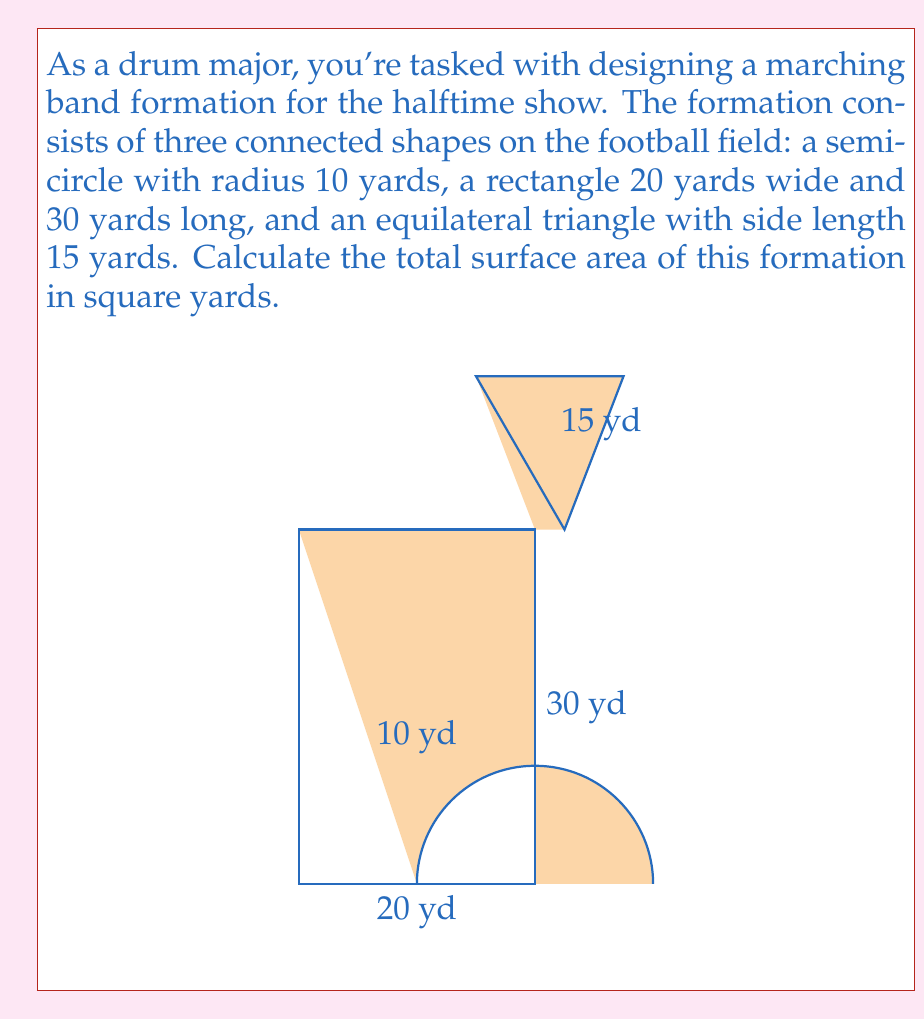Can you solve this math problem? Let's break this down step-by-step:

1) Semicircle area:
   The area of a semicircle is given by $A = \frac{1}{2} \pi r^2$
   $$A_{semicircle} = \frac{1}{2} \pi (10)^2 = 50\pi \text{ square yards}$$

2) Rectangle area:
   The area of a rectangle is length times width
   $$A_{rectangle} = 20 \times 30 = 600 \text{ square yards}$$

3) Equilateral triangle area:
   The area of an equilateral triangle is given by $A = \frac{\sqrt{3}}{4}a^2$, where $a$ is the side length
   $$A_{triangle} = \frac{\sqrt{3}}{4}(15)^2 = \frac{225\sqrt{3}}{4} \text{ square yards}$$

4) Total area:
   Sum all the individual areas
   $$A_{total} = 50\pi + 600 + \frac{225\sqrt{3}}{4}$$

5) Simplify:
   $$A_{total} = 50\pi + 600 + \frac{225\sqrt{3}}{4} \approx 857.17 \text{ square yards}$$
Answer: $50\pi + 600 + \frac{225\sqrt{3}}{4}$ square yards 